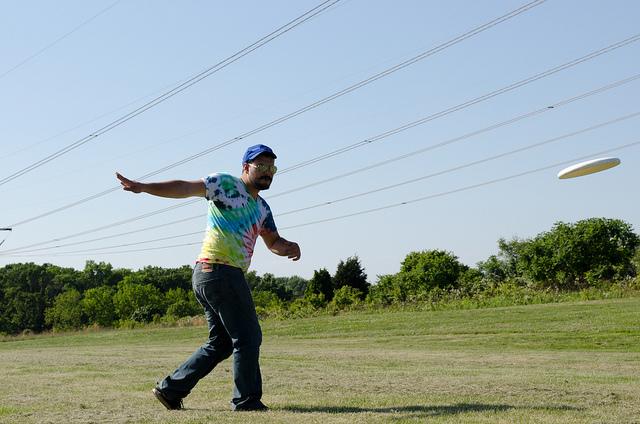What is above the person?
Keep it brief. Power lines. Is the man skating?
Write a very short answer. No. What did this person just throw?
Keep it brief. Frisbee. 